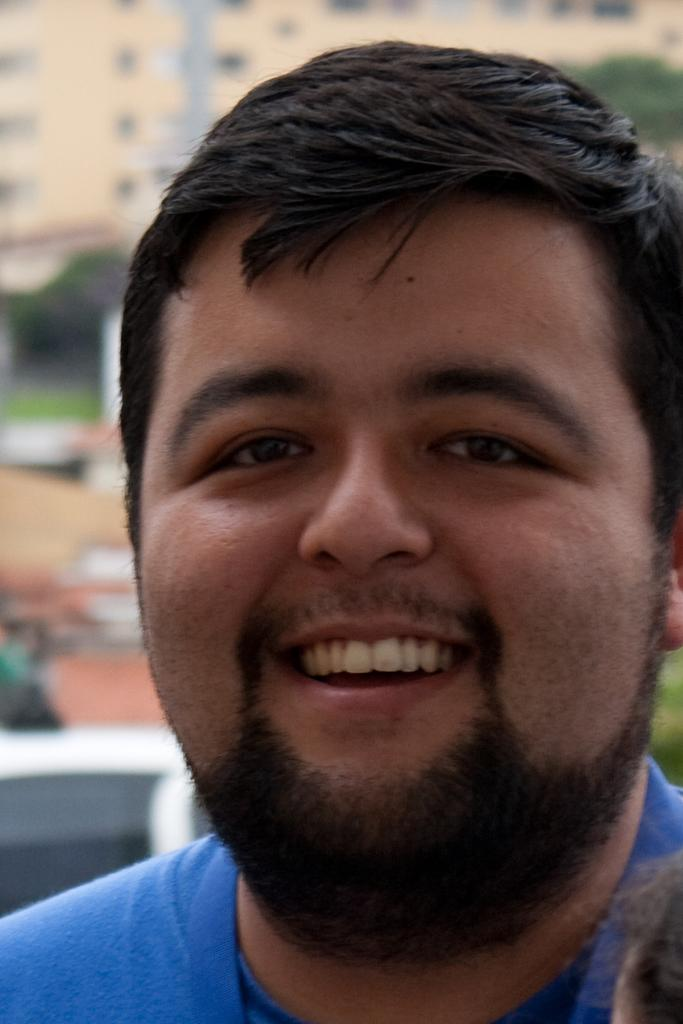Who or what is present in the image? There is a person in the image. What is the person doing or expressing? The person is smiling. What can be seen in the distance behind the person? There are buildings and trees in the background of the image. What type of lunch is the person holding in the image? There is no lunch present in the image; the person is simply smiling. 